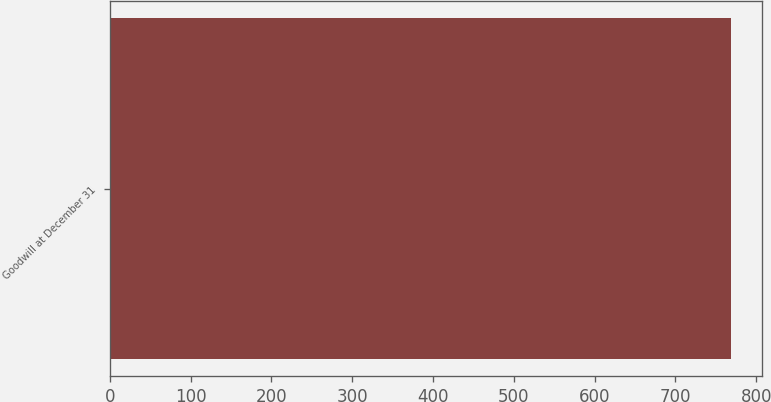Convert chart to OTSL. <chart><loc_0><loc_0><loc_500><loc_500><bar_chart><fcel>Goodwill at December 31<nl><fcel>769.2<nl></chart> 